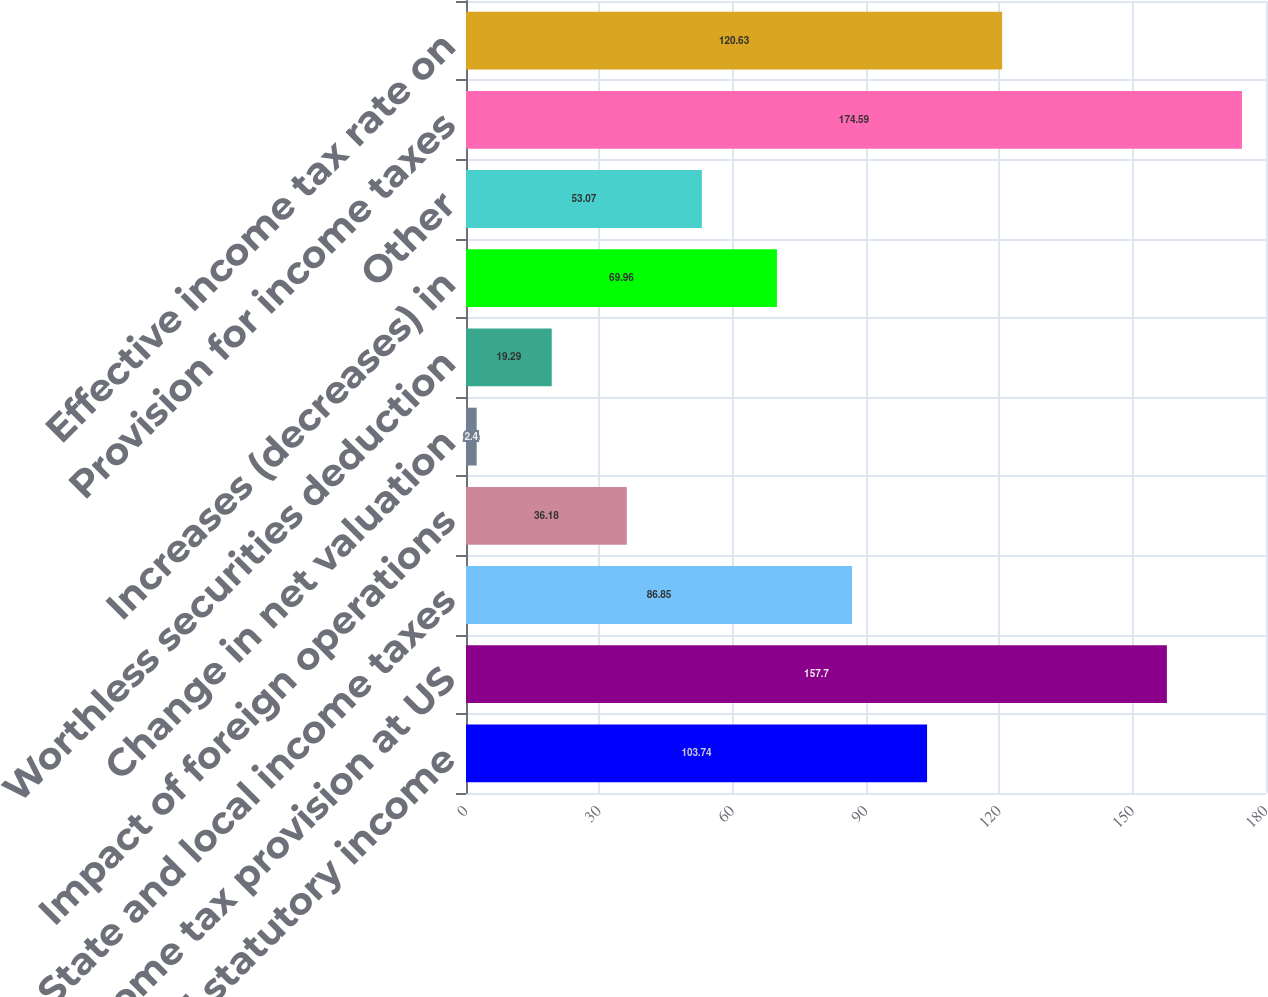Convert chart to OTSL. <chart><loc_0><loc_0><loc_500><loc_500><bar_chart><fcel>US federal statutory income<fcel>Income tax provision at US<fcel>State and local income taxes<fcel>Impact of foreign operations<fcel>Change in net valuation<fcel>Worthless securities deduction<fcel>Increases (decreases) in<fcel>Other<fcel>Provision for income taxes<fcel>Effective income tax rate on<nl><fcel>103.74<fcel>157.7<fcel>86.85<fcel>36.18<fcel>2.4<fcel>19.29<fcel>69.96<fcel>53.07<fcel>174.59<fcel>120.63<nl></chart> 